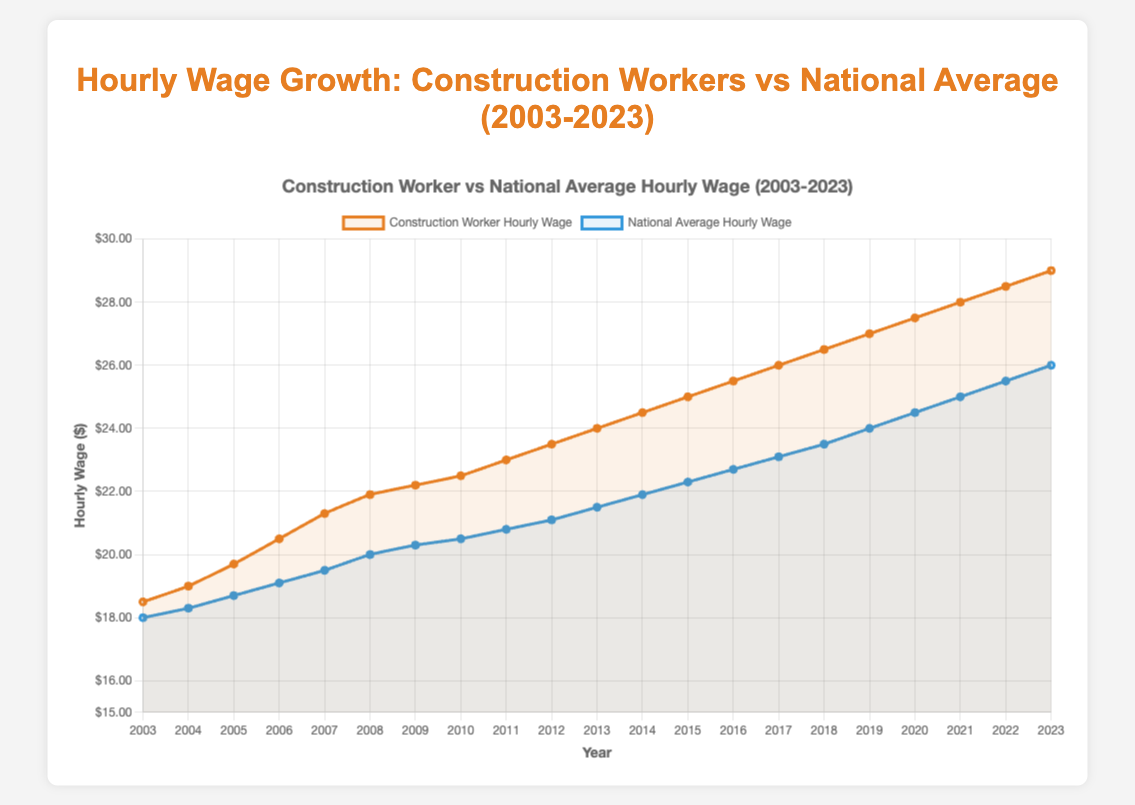What's the hourly wage for construction workers in 2023? Look at the data point for construction workers in the year 2023 on the line plot. The value at that point is $29.00.
Answer: $29.00 How much did the hourly wage for construction workers increase from 2003 to 2023? Subtract the construction worker hourly wage in 2003 from the wage in 2023. That is, 29.00 - 18.50 = 10.50.
Answer: $10.50 What was the national average hourly wage in 2015? Refer to the data point for the national average hourly wage in the year 2015 on the line plot. The value at that point is $22.30.
Answer: $22.30 How does the yearly growth rate compare between construction workers and the national average from 2003 to 2023? Find the total increase for both groups over the period, and then divide by the number of years (20) to find the yearly growth rate. For construction workers, the increase is 29.00 - 18.50 = 10.50, which is 10.50 / 20 = 0.525 per year. For the national average, the increase is 26.00 - 18.00 = 8.00, which is 8.00 / 20 = 0.40 per year. Thus, the yearly growth rate for construction workers is higher.
Answer: Higher for construction workers In which year did the construction workers' hourly wage first surpass $25? Refer to the plot and identify the first year where the construction workers' hourly wage line crosses above the $25 mark. This occurs in the year 2014.
Answer: 2014 Compare the hourly wages of construction workers and the national average in 2010. Which is higher? Find both data points for the year 2010 on the plot. Construction workers have a wage of $22.50, and the national average is $20.50. Thus, the construction workers' wage is higher.
Answer: Construction workers' wage is higher What is the difference between the construction workers' hourly wage and the national average in 2020? Subtract the national average hourly wage in 2020 from the construction workers' hourly wage in the same year. That is, 27.50 - 24.50 = 3.00.
Answer: $3.00 What's the average hourly wage for construction workers over the years 2003 to 2023? Sum up all the yearly wages for construction workers from 2003 to 2023 and then divide by the number of years (21). (18.50 + 19.00 + 19.70 + 20.50 + 21.30 + 21.90 + 22.20 + 22.50 + 23.00 + 23.50 + 24.00 + 24.50 + 25.00 + 25.50 + 26.00 + 26.50 + 27.00 + 27.50 + 28.00 + 28.50 + 29.00) / 21 = 23.81.
Answer: $23.81 During which year did the national average hourly wage reach $21.50? Find the year where the national average hourly wage first reaches $21.50 on the plot. This is the year 2013.
Answer: 2013 